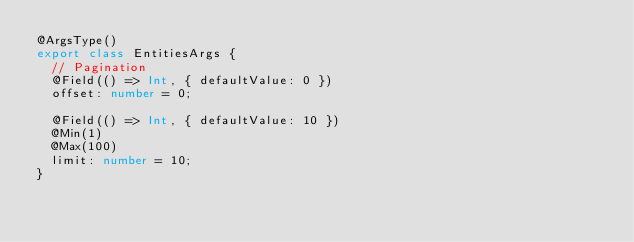<code> <loc_0><loc_0><loc_500><loc_500><_TypeScript_>@ArgsType()
export class EntitiesArgs {
  // Pagination
  @Field(() => Int, { defaultValue: 0 })
  offset: number = 0;

  @Field(() => Int, { defaultValue: 10 })
  @Min(1)
  @Max(100)
  limit: number = 10;
}
</code> 